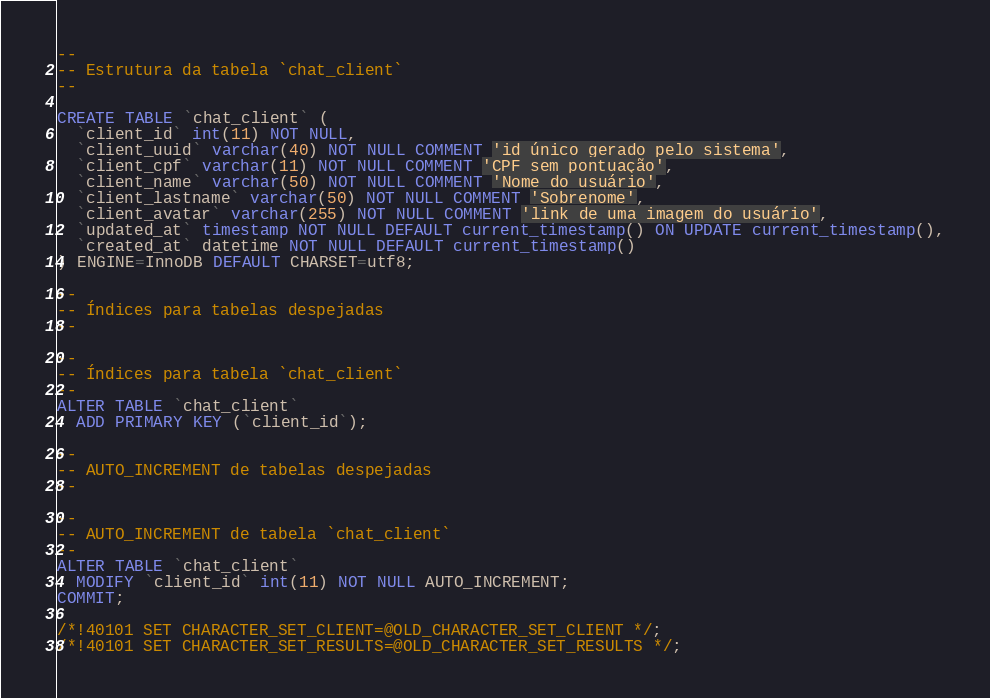<code> <loc_0><loc_0><loc_500><loc_500><_SQL_>
--
-- Estrutura da tabela `chat_client`
--

CREATE TABLE `chat_client` (
  `client_id` int(11) NOT NULL,
  `client_uuid` varchar(40) NOT NULL COMMENT 'id único gerado pelo sistema',
  `client_cpf` varchar(11) NOT NULL COMMENT 'CPF sem pontuação',
  `client_name` varchar(50) NOT NULL COMMENT 'Nome do usuário',
  `client_lastname` varchar(50) NOT NULL COMMENT 'Sobrenome',
  `client_avatar` varchar(255) NOT NULL COMMENT 'link de uma imagem do usuário',
  `updated_at` timestamp NOT NULL DEFAULT current_timestamp() ON UPDATE current_timestamp(),
  `created_at` datetime NOT NULL DEFAULT current_timestamp()
) ENGINE=InnoDB DEFAULT CHARSET=utf8;

--
-- Índices para tabelas despejadas
--

--
-- Índices para tabela `chat_client`
--
ALTER TABLE `chat_client`
  ADD PRIMARY KEY (`client_id`);

--
-- AUTO_INCREMENT de tabelas despejadas
--

--
-- AUTO_INCREMENT de tabela `chat_client`
--
ALTER TABLE `chat_client`
  MODIFY `client_id` int(11) NOT NULL AUTO_INCREMENT;
COMMIT;

/*!40101 SET CHARACTER_SET_CLIENT=@OLD_CHARACTER_SET_CLIENT */;
/*!40101 SET CHARACTER_SET_RESULTS=@OLD_CHARACTER_SET_RESULTS */;</code> 